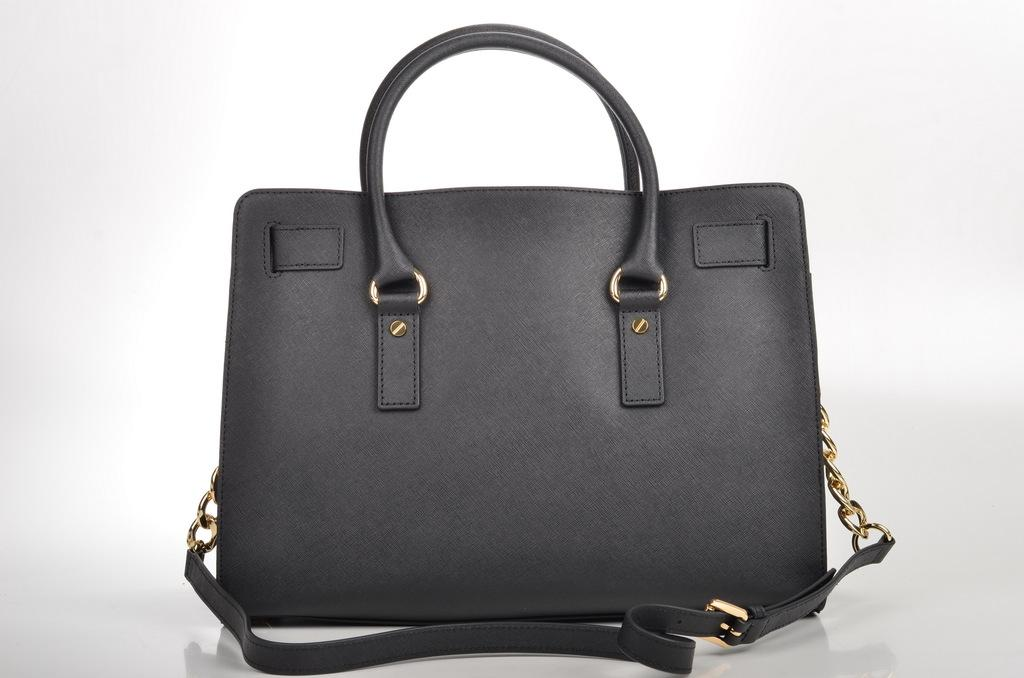What type of accessory is in the image? There is a black handbag in the image. What is attached to the handbag? The handbag has a chain. How many straps make up the chain? The chain consists of one strap. What type of soda is being poured into the pail in the image? There is no soda or pail present in the image; it features a black handbag with a chain. How does the handbag show respect in the image? The handbag does not show respect in the image; it is an inanimate object and cannot display emotions or actions. 